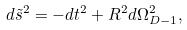Convert formula to latex. <formula><loc_0><loc_0><loc_500><loc_500>d \tilde { s } ^ { 2 } = - d t ^ { 2 } + R ^ { 2 } d \Omega ^ { 2 } _ { D - 1 } ,</formula> 